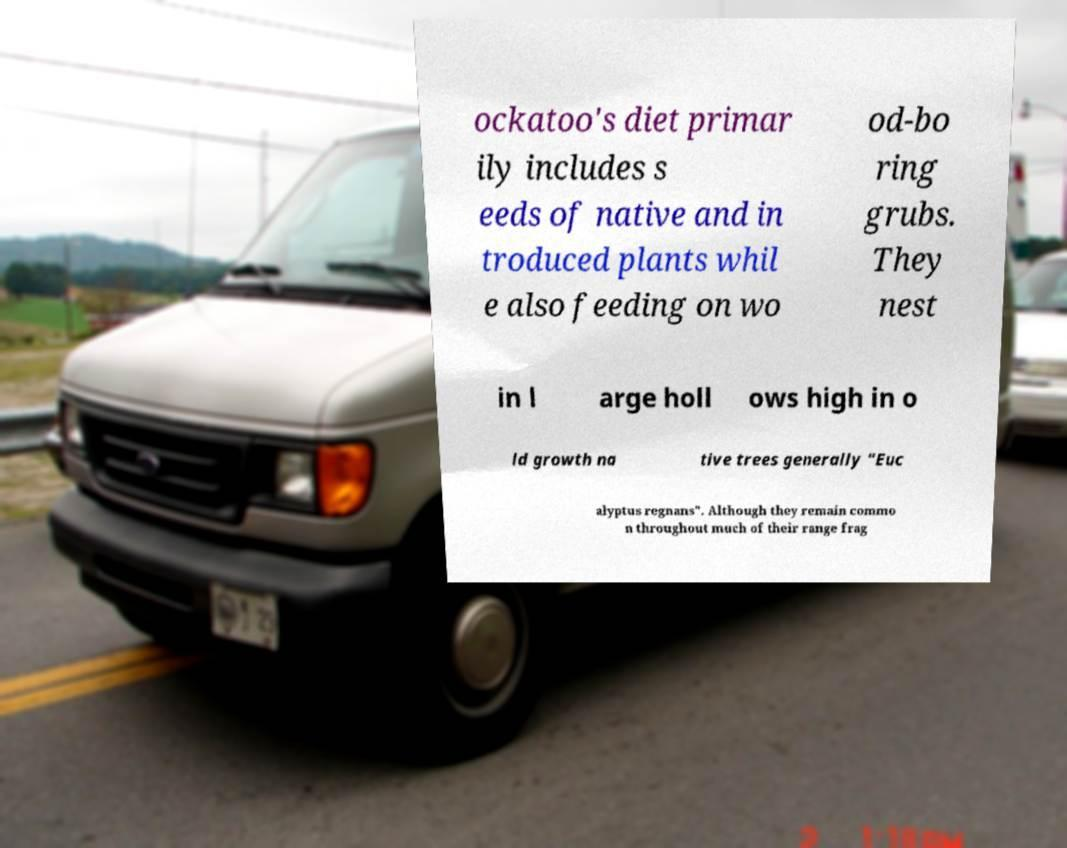There's text embedded in this image that I need extracted. Can you transcribe it verbatim? ockatoo's diet primar ily includes s eeds of native and in troduced plants whil e also feeding on wo od-bo ring grubs. They nest in l arge holl ows high in o ld growth na tive trees generally "Euc alyptus regnans". Although they remain commo n throughout much of their range frag 